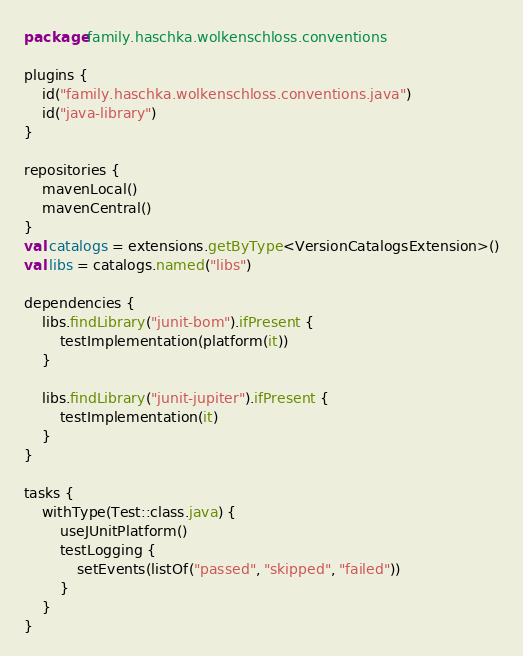<code> <loc_0><loc_0><loc_500><loc_500><_Kotlin_>package family.haschka.wolkenschloss.conventions

plugins {
    id("family.haschka.wolkenschloss.conventions.java")
    id("java-library")
}

repositories {
    mavenLocal()
    mavenCentral()
}
val catalogs = extensions.getByType<VersionCatalogsExtension>()
val libs = catalogs.named("libs")

dependencies {
    libs.findLibrary("junit-bom").ifPresent {
        testImplementation(platform(it))
    }

    libs.findLibrary("junit-jupiter").ifPresent {
        testImplementation(it)
    }
}

tasks {
    withType(Test::class.java) {
        useJUnitPlatform()
        testLogging {
            setEvents(listOf("passed", "skipped", "failed"))
        }
    }
}</code> 